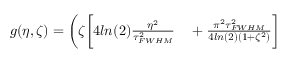<formula> <loc_0><loc_0><loc_500><loc_500>\begin{array} { r l } { g ( \eta , \zeta ) = \Big ( \zeta \Big [ 4 \ln ( 2 ) \frac { \eta ^ { 2 } } { \tau _ { F W H M } ^ { 2 } } } & + \frac { \pi ^ { 2 } \tau _ { F W H M } ^ { 2 } } { 4 \ln ( 2 ) ( 1 + \zeta ^ { 2 } ) } \Big ] } \end{array}</formula> 